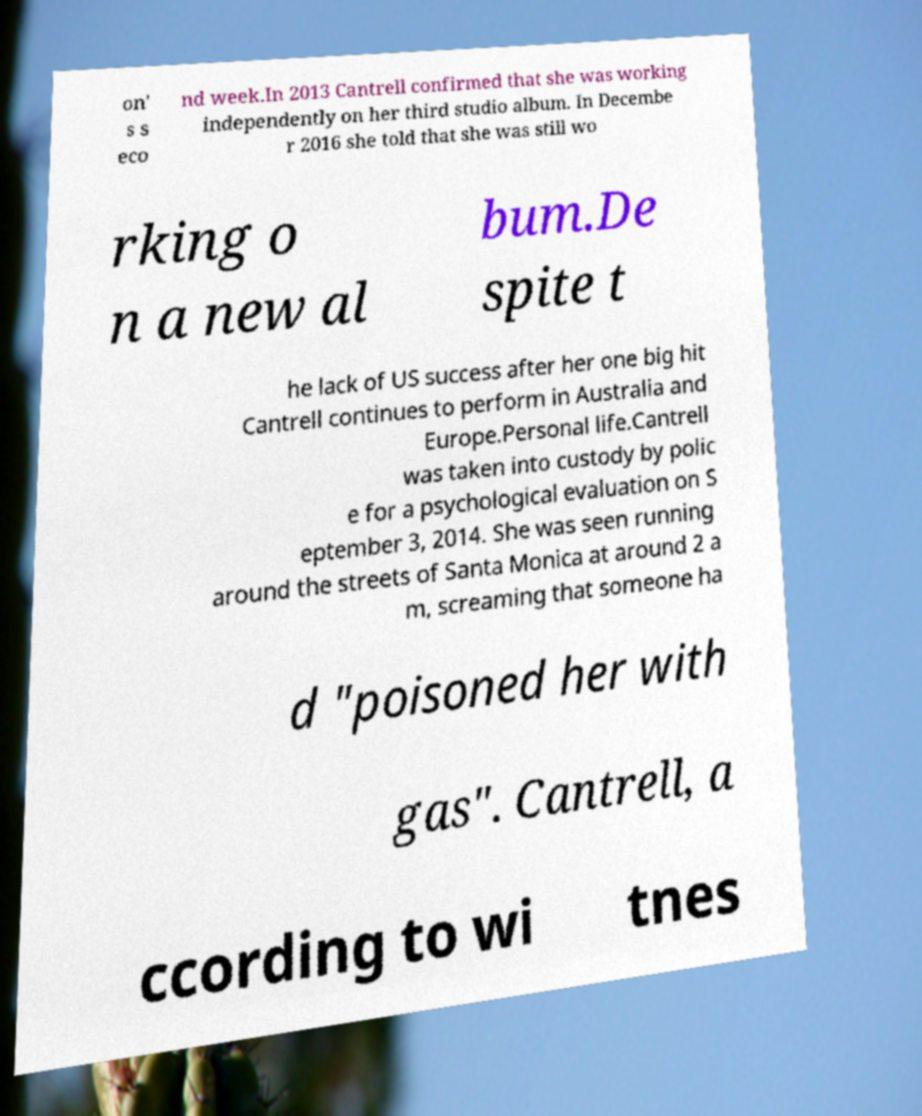There's text embedded in this image that I need extracted. Can you transcribe it verbatim? on' s s eco nd week.In 2013 Cantrell confirmed that she was working independently on her third studio album. In Decembe r 2016 she told that she was still wo rking o n a new al bum.De spite t he lack of US success after her one big hit Cantrell continues to perform in Australia and Europe.Personal life.Cantrell was taken into custody by polic e for a psychological evaluation on S eptember 3, 2014. She was seen running around the streets of Santa Monica at around 2 a m, screaming that someone ha d "poisoned her with gas". Cantrell, a ccording to wi tnes 